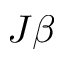Convert formula to latex. <formula><loc_0><loc_0><loc_500><loc_500>J \beta</formula> 